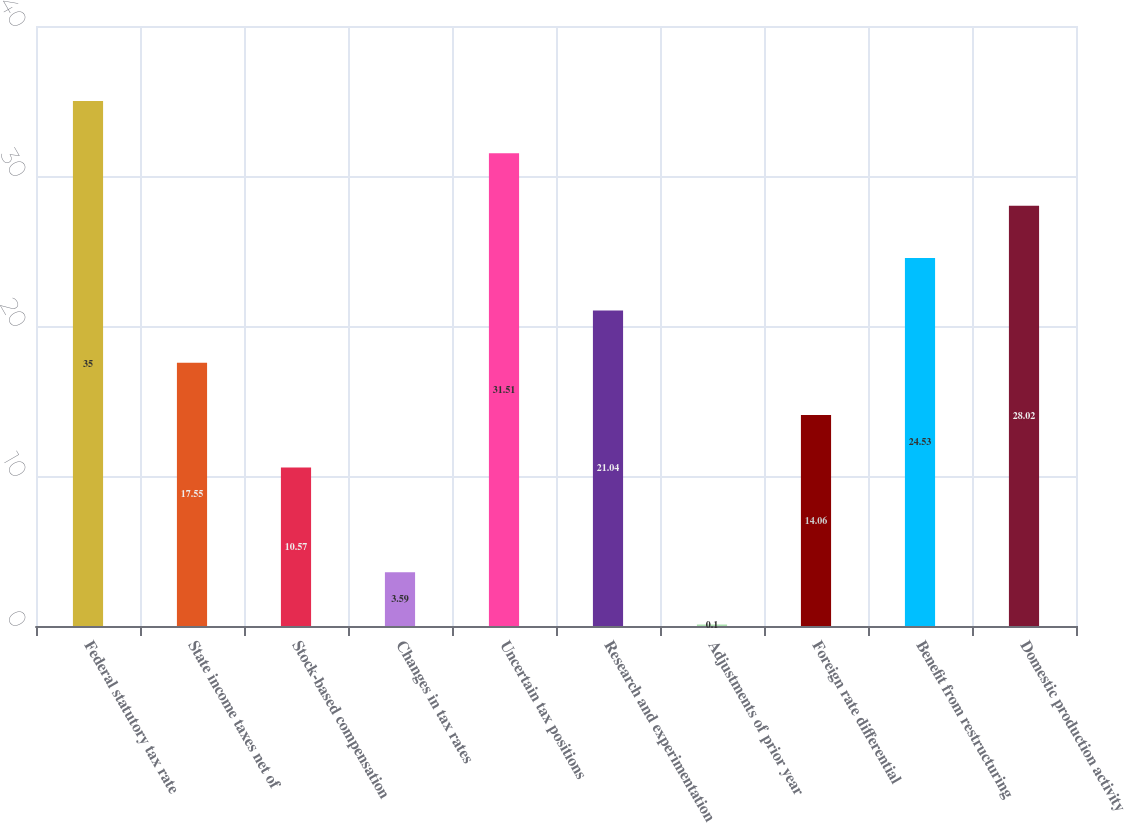Convert chart to OTSL. <chart><loc_0><loc_0><loc_500><loc_500><bar_chart><fcel>Federal statutory tax rate<fcel>State income taxes net of<fcel>Stock-based compensation<fcel>Changes in tax rates<fcel>Uncertain tax positions<fcel>Research and experimentation<fcel>Adjustments of prior year<fcel>Foreign rate differential<fcel>Benefit from restructuring<fcel>Domestic production activity<nl><fcel>35<fcel>17.55<fcel>10.57<fcel>3.59<fcel>31.51<fcel>21.04<fcel>0.1<fcel>14.06<fcel>24.53<fcel>28.02<nl></chart> 